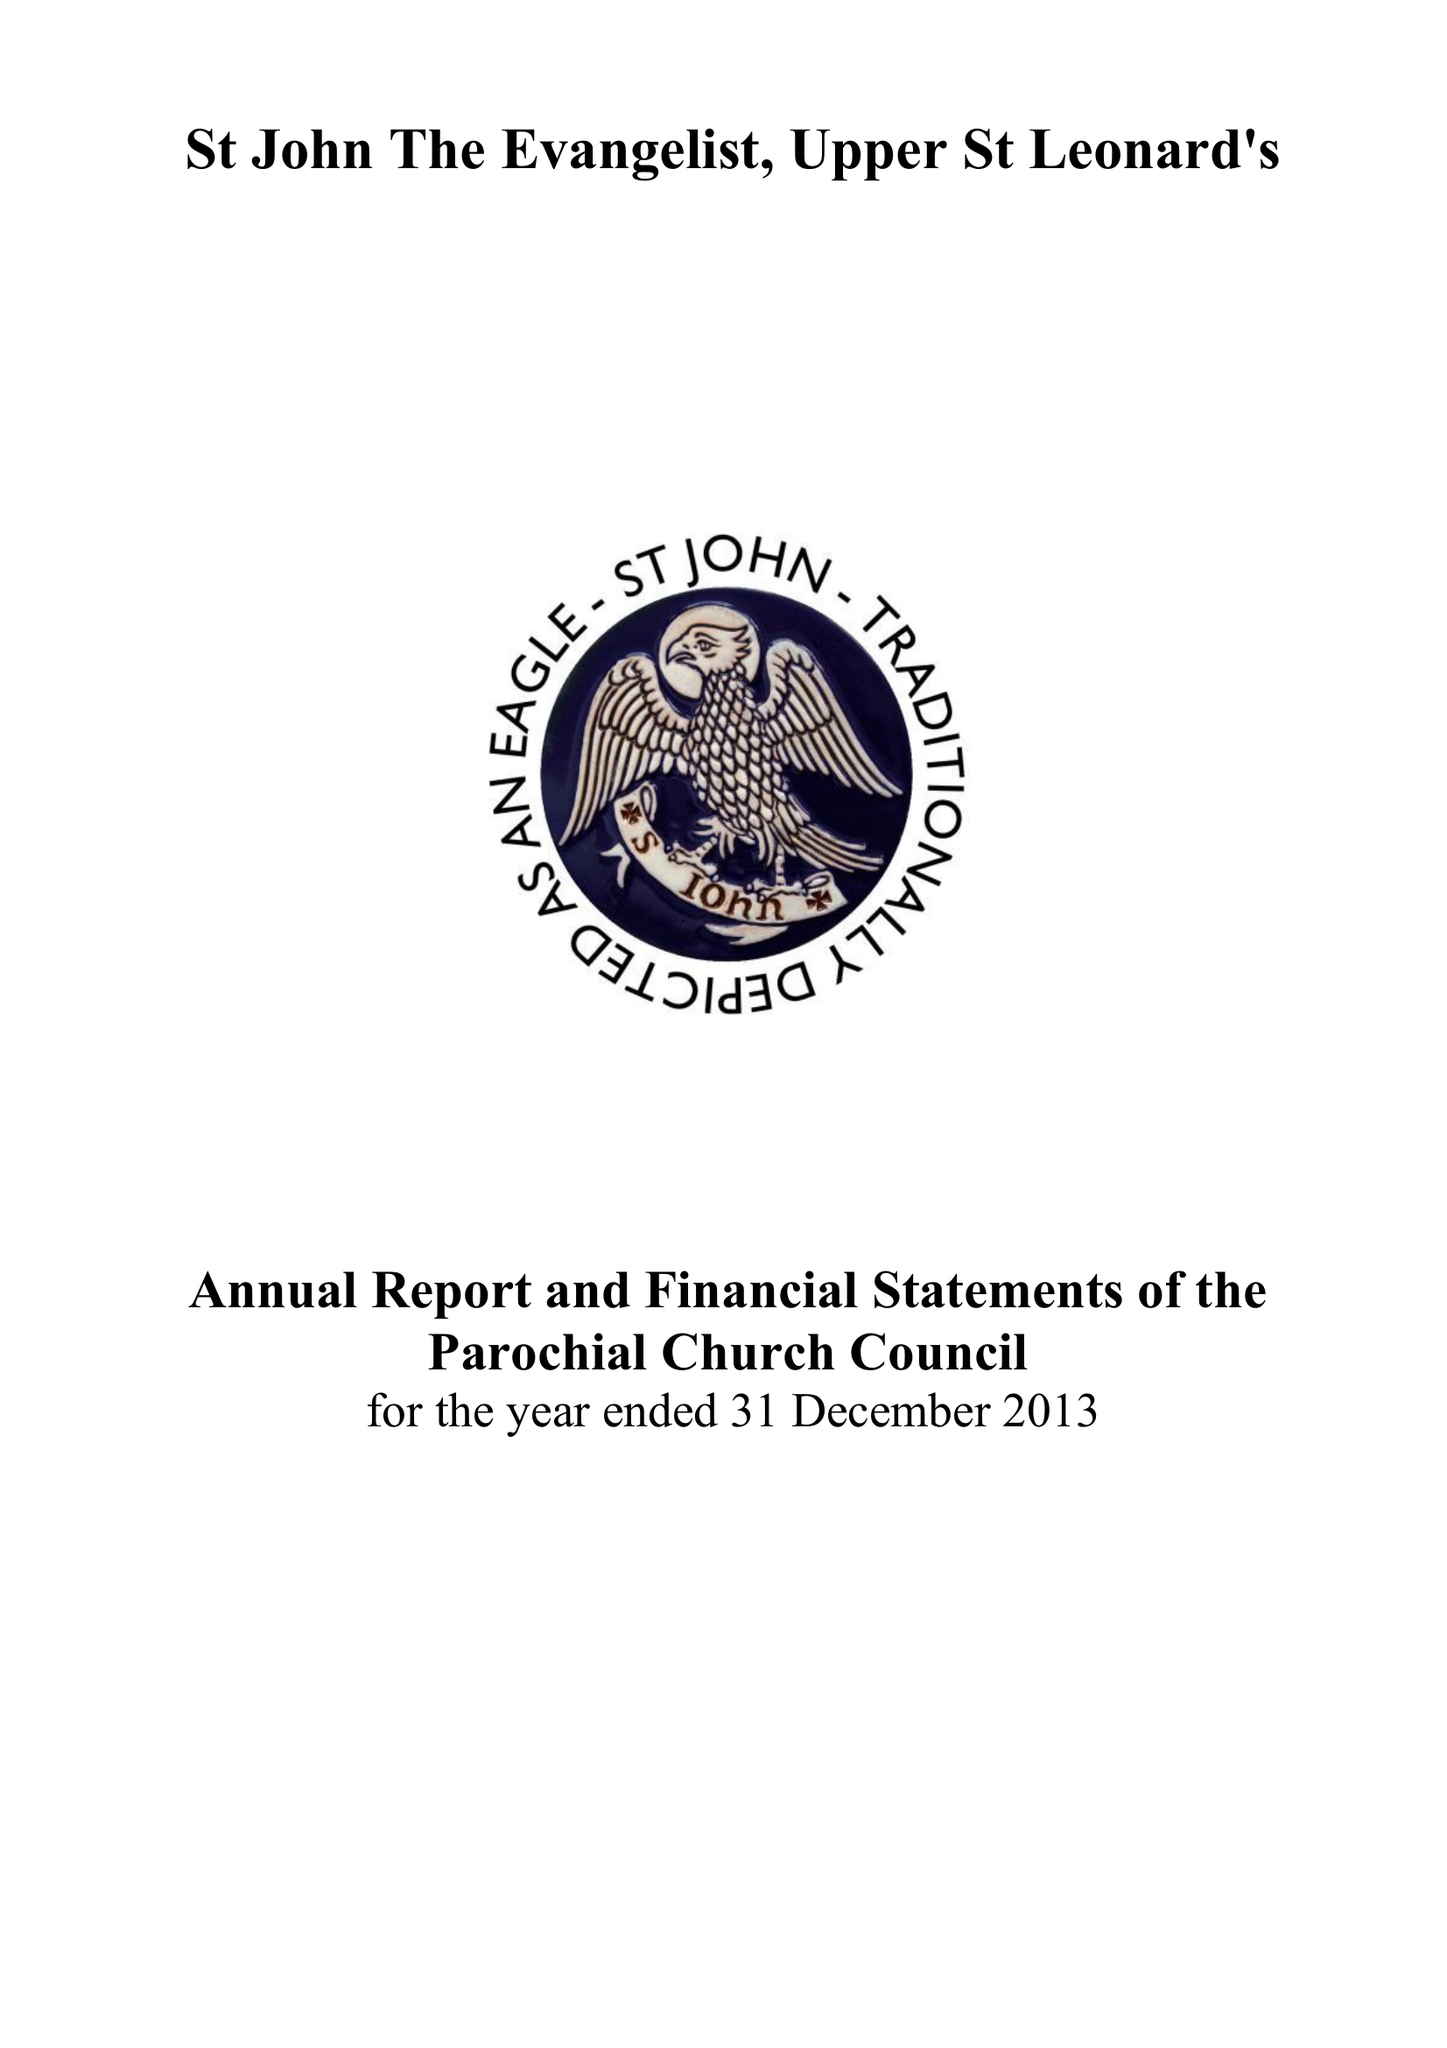What is the value for the charity_number?
Answer the question using a single word or phrase. 1132339 